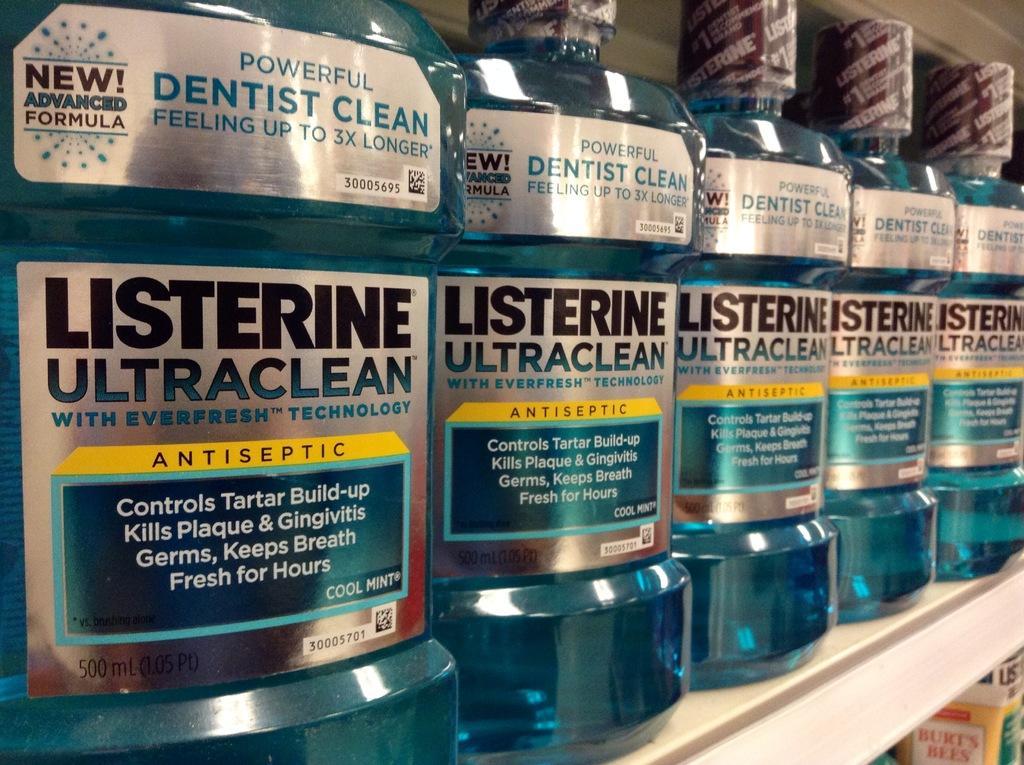Can you describe this image briefly? In this image few bottles are on the shelf having label as listerine ultra clean. 